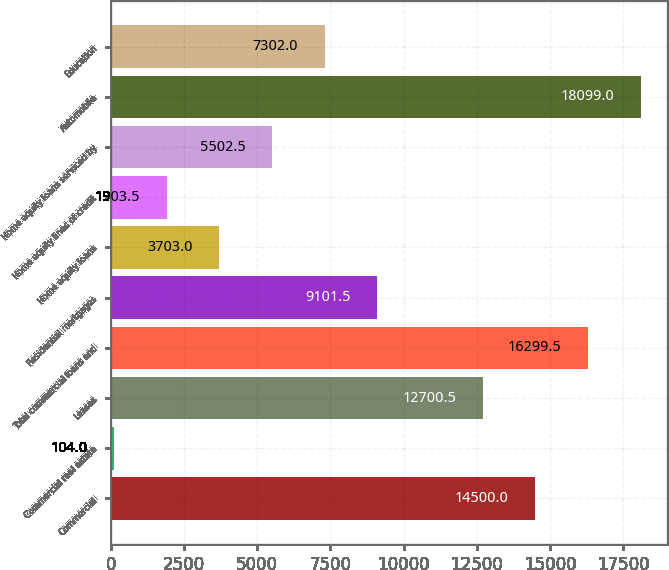<chart> <loc_0><loc_0><loc_500><loc_500><bar_chart><fcel>Commercial<fcel>Commercial real estate<fcel>Leases<fcel>Total commercial loans and<fcel>Residential mortgages<fcel>Home equity loans<fcel>Home equity lines of credit<fcel>Home equity loans serviced by<fcel>Automobile<fcel>Education<nl><fcel>14500<fcel>104<fcel>12700.5<fcel>16299.5<fcel>9101.5<fcel>3703<fcel>1903.5<fcel>5502.5<fcel>18099<fcel>7302<nl></chart> 